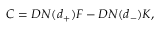Convert formula to latex. <formula><loc_0><loc_0><loc_500><loc_500>C = D N ( d _ { + } ) F - D N ( d _ { - } ) K ,</formula> 